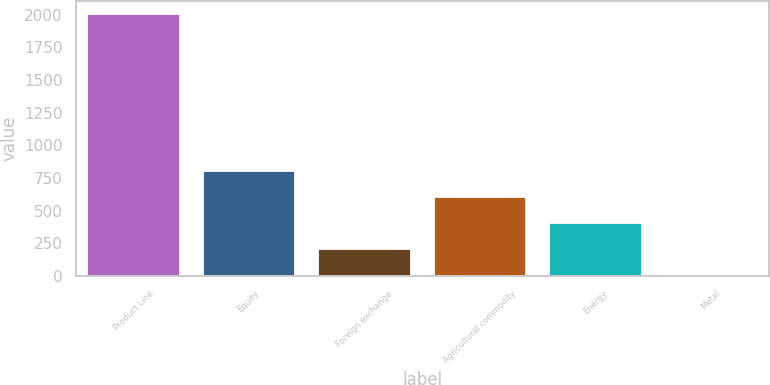Convert chart to OTSL. <chart><loc_0><loc_0><loc_500><loc_500><bar_chart><fcel>Product Line<fcel>Equity<fcel>Foreign exchange<fcel>Agricultural commodity<fcel>Energy<fcel>Metal<nl><fcel>2008<fcel>803.8<fcel>201.7<fcel>603.1<fcel>402.4<fcel>1<nl></chart> 